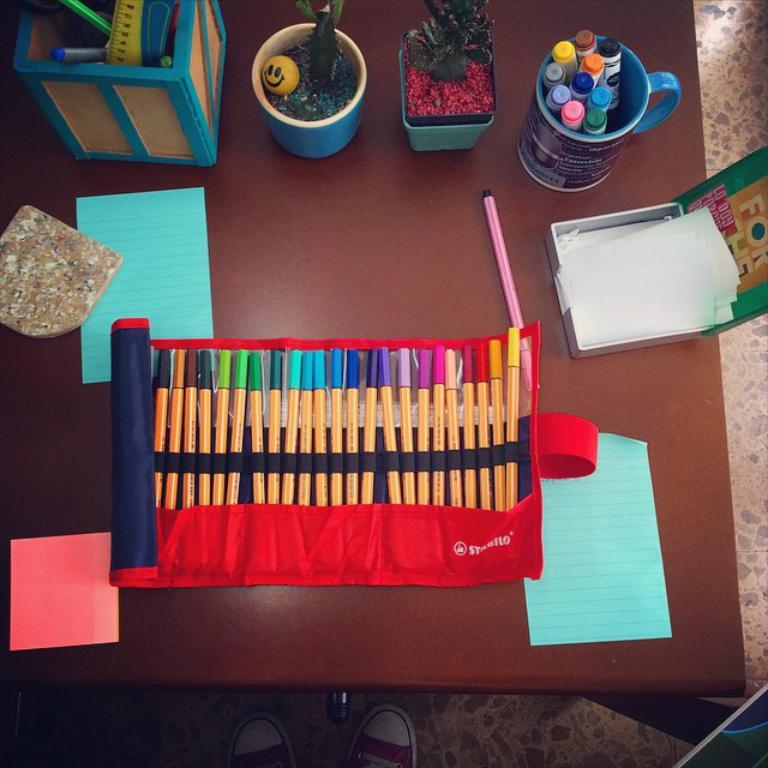What is inside the cup in the image? There are sketches in a cup in the image. What tools are used for drawing in the image? There are pens in the image. What is used for writing or drawing on in the image? There are papers in the image. What container is present in the image? There is a box in the image. Where are all these items located? All these items are placed on a table. What can be seen on the floor beside the table? There are shoes on the floor beside the table. What type of jewel is placed on top of the box in the image? There is no jewel present in the image; it only contains sketches in a cup, pens, papers, and a box. Can you see any bubbles floating around the shoes on the floor? There are no bubbles present in the image; it only shows shoes on the floor beside the table. 